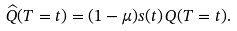<formula> <loc_0><loc_0><loc_500><loc_500>\widehat { Q } ( T = t ) = ( 1 - \mu ) s ( t ) \, Q ( T = t ) .</formula> 